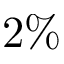<formula> <loc_0><loc_0><loc_500><loc_500>2 \%</formula> 